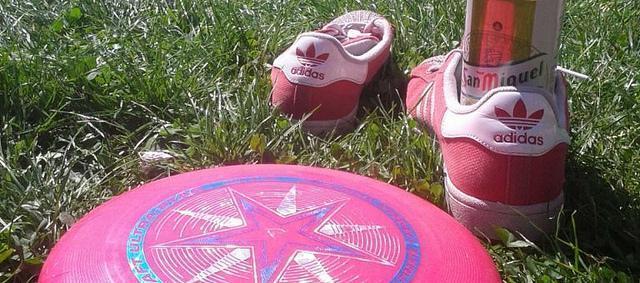How many frisbees are in the picture?
Give a very brief answer. 1. 